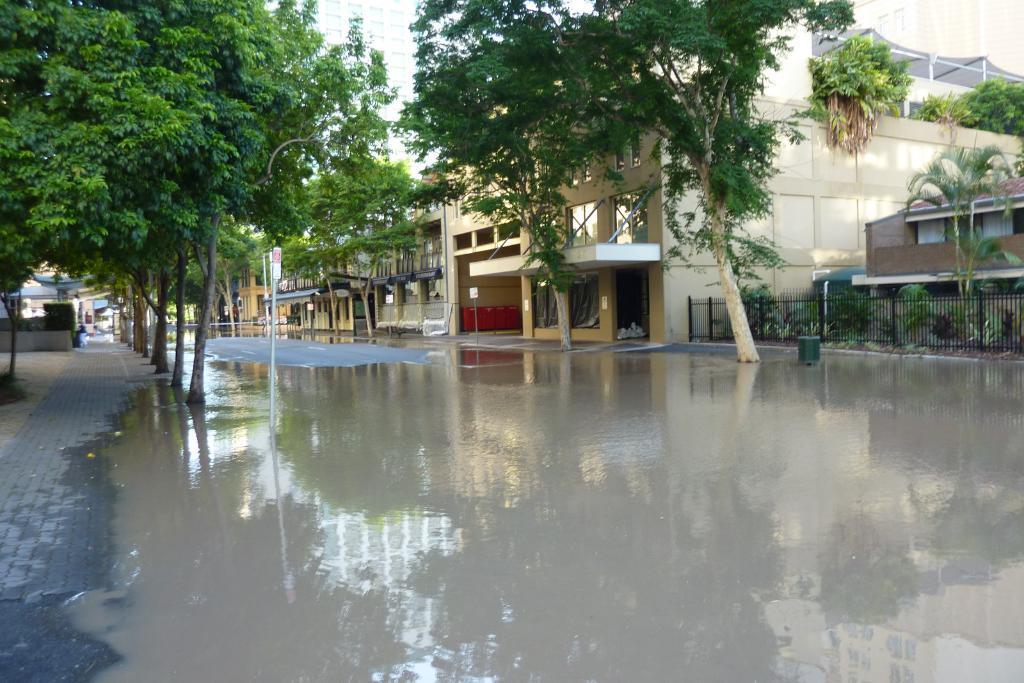In one or two sentences, can you explain what this image depicts? In this image in front there is water. In the center of the image there is a road. There are boards. On the right side of the image there is a metal fence. In the background of the image there are trees and buildings. 